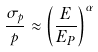<formula> <loc_0><loc_0><loc_500><loc_500>\frac { \sigma _ { p } } { p } \approx \left ( \frac { E } { E _ { P } } \right ) ^ { \alpha }</formula> 